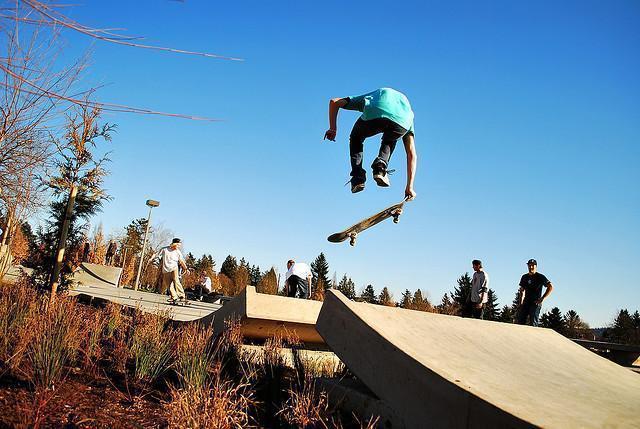Why is he grabbing the board?
Choose the correct response, then elucidate: 'Answer: answer
Rationale: rationale.'
Options: Remove it, hold on, stop stealing, keep it. Answer: keep it.
Rationale: A skateboarder is holding onto the tip of a skateboard as he goes over a jump. 